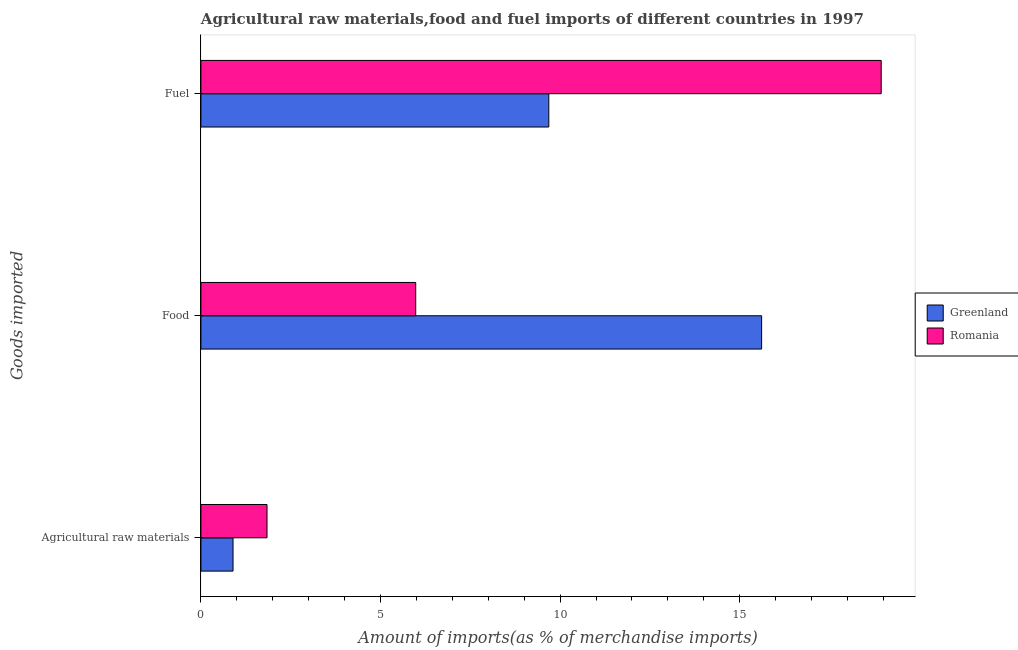How many different coloured bars are there?
Make the answer very short. 2. How many groups of bars are there?
Provide a succinct answer. 3. How many bars are there on the 1st tick from the top?
Your answer should be compact. 2. What is the label of the 2nd group of bars from the top?
Give a very brief answer. Food. What is the percentage of raw materials imports in Greenland?
Offer a very short reply. 0.89. Across all countries, what is the maximum percentage of fuel imports?
Your answer should be very brief. 18.94. Across all countries, what is the minimum percentage of raw materials imports?
Your response must be concise. 0.89. In which country was the percentage of food imports maximum?
Ensure brevity in your answer.  Greenland. In which country was the percentage of raw materials imports minimum?
Offer a terse response. Greenland. What is the total percentage of raw materials imports in the graph?
Offer a terse response. 2.73. What is the difference between the percentage of fuel imports in Romania and that in Greenland?
Provide a succinct answer. 9.25. What is the difference between the percentage of food imports in Greenland and the percentage of fuel imports in Romania?
Offer a terse response. -3.33. What is the average percentage of food imports per country?
Ensure brevity in your answer.  10.79. What is the difference between the percentage of food imports and percentage of fuel imports in Romania?
Give a very brief answer. -12.96. In how many countries, is the percentage of food imports greater than 13 %?
Ensure brevity in your answer.  1. What is the ratio of the percentage of food imports in Romania to that in Greenland?
Your response must be concise. 0.38. Is the percentage of raw materials imports in Greenland less than that in Romania?
Keep it short and to the point. Yes. What is the difference between the highest and the second highest percentage of food imports?
Your response must be concise. 9.63. What is the difference between the highest and the lowest percentage of fuel imports?
Provide a short and direct response. 9.25. In how many countries, is the percentage of raw materials imports greater than the average percentage of raw materials imports taken over all countries?
Make the answer very short. 1. What does the 1st bar from the top in Food represents?
Provide a succinct answer. Romania. What does the 1st bar from the bottom in Fuel represents?
Provide a short and direct response. Greenland. Is it the case that in every country, the sum of the percentage of raw materials imports and percentage of food imports is greater than the percentage of fuel imports?
Offer a terse response. No. How many bars are there?
Keep it short and to the point. 6. Are all the bars in the graph horizontal?
Keep it short and to the point. Yes. How many countries are there in the graph?
Provide a succinct answer. 2. What is the difference between two consecutive major ticks on the X-axis?
Offer a very short reply. 5. Does the graph contain any zero values?
Provide a short and direct response. No. Does the graph contain grids?
Offer a very short reply. No. Where does the legend appear in the graph?
Your answer should be very brief. Center right. What is the title of the graph?
Make the answer very short. Agricultural raw materials,food and fuel imports of different countries in 1997. Does "Small states" appear as one of the legend labels in the graph?
Offer a very short reply. No. What is the label or title of the X-axis?
Ensure brevity in your answer.  Amount of imports(as % of merchandise imports). What is the label or title of the Y-axis?
Offer a terse response. Goods imported. What is the Amount of imports(as % of merchandise imports) in Greenland in Agricultural raw materials?
Make the answer very short. 0.89. What is the Amount of imports(as % of merchandise imports) in Romania in Agricultural raw materials?
Your response must be concise. 1.84. What is the Amount of imports(as % of merchandise imports) of Greenland in Food?
Provide a succinct answer. 15.61. What is the Amount of imports(as % of merchandise imports) of Romania in Food?
Your answer should be very brief. 5.98. What is the Amount of imports(as % of merchandise imports) of Greenland in Fuel?
Your answer should be compact. 9.68. What is the Amount of imports(as % of merchandise imports) of Romania in Fuel?
Keep it short and to the point. 18.94. Across all Goods imported, what is the maximum Amount of imports(as % of merchandise imports) in Greenland?
Ensure brevity in your answer.  15.61. Across all Goods imported, what is the maximum Amount of imports(as % of merchandise imports) of Romania?
Give a very brief answer. 18.94. Across all Goods imported, what is the minimum Amount of imports(as % of merchandise imports) of Greenland?
Provide a succinct answer. 0.89. Across all Goods imported, what is the minimum Amount of imports(as % of merchandise imports) of Romania?
Give a very brief answer. 1.84. What is the total Amount of imports(as % of merchandise imports) in Greenland in the graph?
Provide a succinct answer. 26.19. What is the total Amount of imports(as % of merchandise imports) of Romania in the graph?
Offer a very short reply. 26.76. What is the difference between the Amount of imports(as % of merchandise imports) of Greenland in Agricultural raw materials and that in Food?
Provide a short and direct response. -14.71. What is the difference between the Amount of imports(as % of merchandise imports) in Romania in Agricultural raw materials and that in Food?
Offer a very short reply. -4.14. What is the difference between the Amount of imports(as % of merchandise imports) in Greenland in Agricultural raw materials and that in Fuel?
Offer a terse response. -8.79. What is the difference between the Amount of imports(as % of merchandise imports) in Romania in Agricultural raw materials and that in Fuel?
Provide a succinct answer. -17.1. What is the difference between the Amount of imports(as % of merchandise imports) of Greenland in Food and that in Fuel?
Offer a very short reply. 5.92. What is the difference between the Amount of imports(as % of merchandise imports) of Romania in Food and that in Fuel?
Ensure brevity in your answer.  -12.96. What is the difference between the Amount of imports(as % of merchandise imports) of Greenland in Agricultural raw materials and the Amount of imports(as % of merchandise imports) of Romania in Food?
Ensure brevity in your answer.  -5.09. What is the difference between the Amount of imports(as % of merchandise imports) of Greenland in Agricultural raw materials and the Amount of imports(as % of merchandise imports) of Romania in Fuel?
Keep it short and to the point. -18.04. What is the difference between the Amount of imports(as % of merchandise imports) in Greenland in Food and the Amount of imports(as % of merchandise imports) in Romania in Fuel?
Offer a very short reply. -3.33. What is the average Amount of imports(as % of merchandise imports) in Greenland per Goods imported?
Offer a very short reply. 8.73. What is the average Amount of imports(as % of merchandise imports) in Romania per Goods imported?
Give a very brief answer. 8.92. What is the difference between the Amount of imports(as % of merchandise imports) in Greenland and Amount of imports(as % of merchandise imports) in Romania in Agricultural raw materials?
Your answer should be very brief. -0.95. What is the difference between the Amount of imports(as % of merchandise imports) of Greenland and Amount of imports(as % of merchandise imports) of Romania in Food?
Make the answer very short. 9.63. What is the difference between the Amount of imports(as % of merchandise imports) of Greenland and Amount of imports(as % of merchandise imports) of Romania in Fuel?
Your answer should be very brief. -9.25. What is the ratio of the Amount of imports(as % of merchandise imports) of Greenland in Agricultural raw materials to that in Food?
Provide a short and direct response. 0.06. What is the ratio of the Amount of imports(as % of merchandise imports) in Romania in Agricultural raw materials to that in Food?
Make the answer very short. 0.31. What is the ratio of the Amount of imports(as % of merchandise imports) in Greenland in Agricultural raw materials to that in Fuel?
Provide a succinct answer. 0.09. What is the ratio of the Amount of imports(as % of merchandise imports) in Romania in Agricultural raw materials to that in Fuel?
Provide a short and direct response. 0.1. What is the ratio of the Amount of imports(as % of merchandise imports) of Greenland in Food to that in Fuel?
Your response must be concise. 1.61. What is the ratio of the Amount of imports(as % of merchandise imports) of Romania in Food to that in Fuel?
Offer a very short reply. 0.32. What is the difference between the highest and the second highest Amount of imports(as % of merchandise imports) in Greenland?
Offer a terse response. 5.92. What is the difference between the highest and the second highest Amount of imports(as % of merchandise imports) in Romania?
Your answer should be very brief. 12.96. What is the difference between the highest and the lowest Amount of imports(as % of merchandise imports) in Greenland?
Your response must be concise. 14.71. What is the difference between the highest and the lowest Amount of imports(as % of merchandise imports) in Romania?
Make the answer very short. 17.1. 